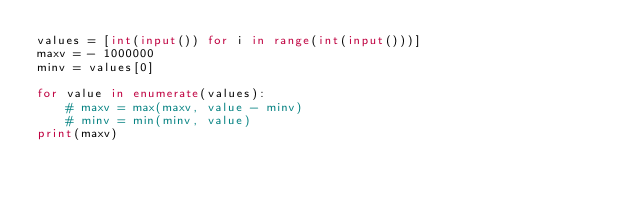<code> <loc_0><loc_0><loc_500><loc_500><_Python_>values = [int(input()) for i in range(int(input()))]
maxv = - 1000000
minv = values[0]

for value in enumerate(values):
    # maxv = max(maxv, value - minv)
    # minv = min(minv, value)
print(maxv)
</code> 